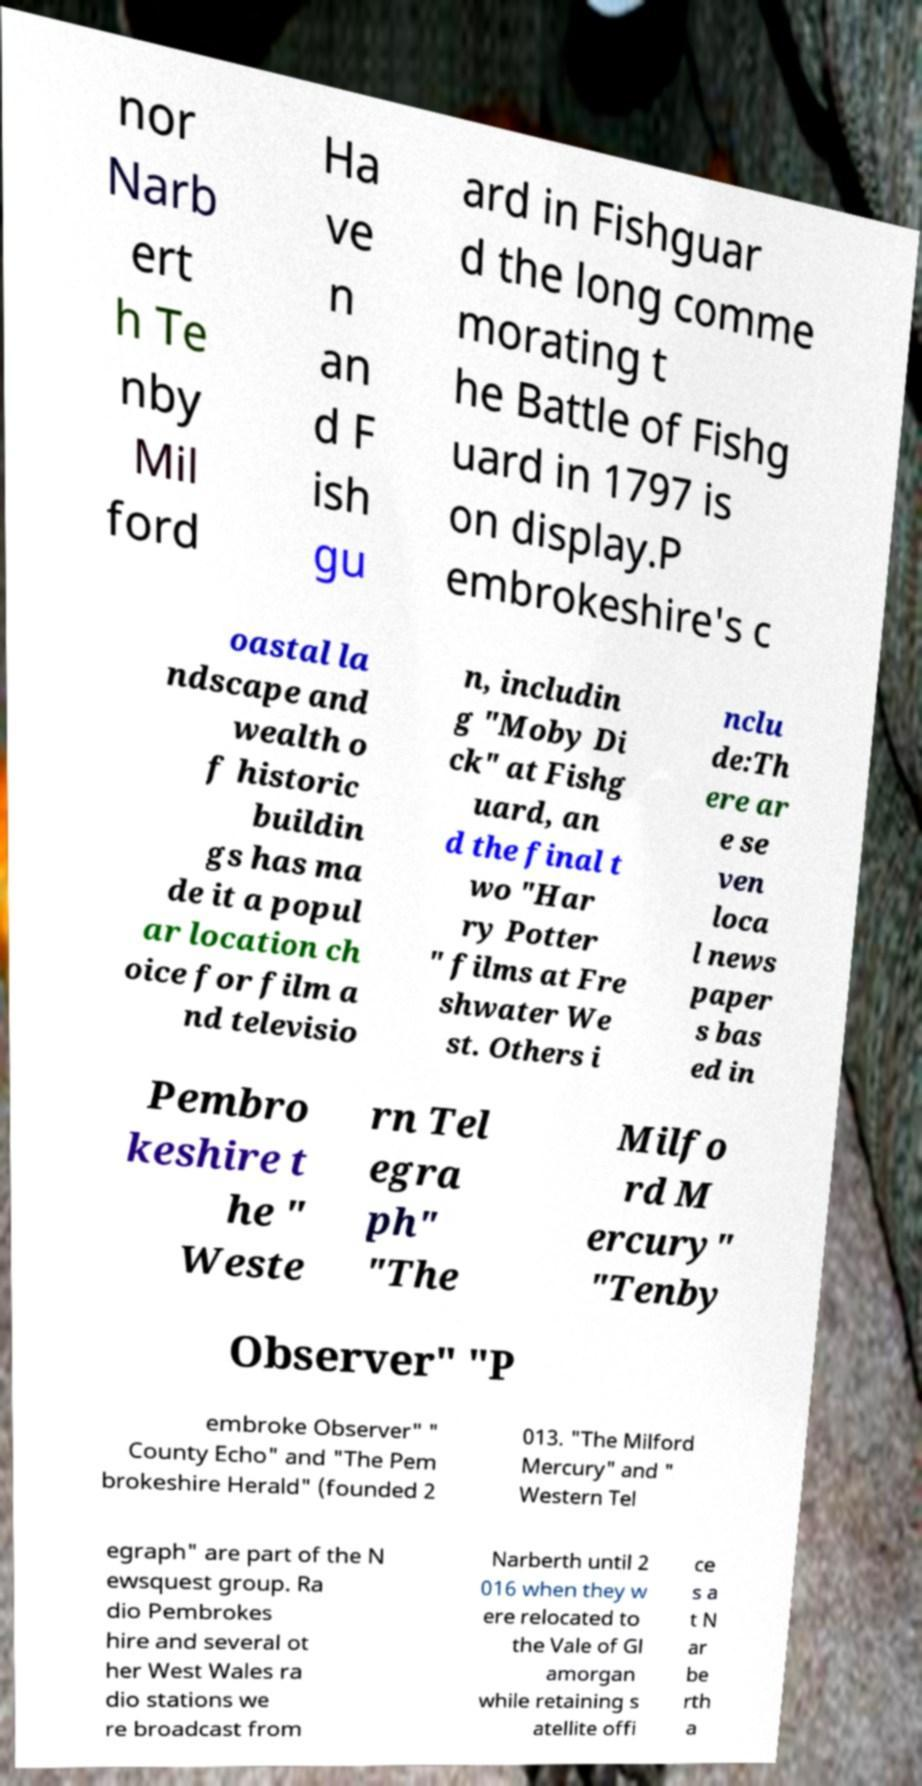I need the written content from this picture converted into text. Can you do that? nor Narb ert h Te nby Mil ford Ha ve n an d F ish gu ard in Fishguar d the long comme morating t he Battle of Fishg uard in 1797 is on display.P embrokeshire's c oastal la ndscape and wealth o f historic buildin gs has ma de it a popul ar location ch oice for film a nd televisio n, includin g "Moby Di ck" at Fishg uard, an d the final t wo "Har ry Potter " films at Fre shwater We st. Others i nclu de:Th ere ar e se ven loca l news paper s bas ed in Pembro keshire t he " Weste rn Tel egra ph" "The Milfo rd M ercury" "Tenby Observer" "P embroke Observer" " County Echo" and "The Pem brokeshire Herald" (founded 2 013. "The Milford Mercury" and " Western Tel egraph" are part of the N ewsquest group. Ra dio Pembrokes hire and several ot her West Wales ra dio stations we re broadcast from Narberth until 2 016 when they w ere relocated to the Vale of Gl amorgan while retaining s atellite offi ce s a t N ar be rth a 